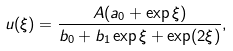<formula> <loc_0><loc_0><loc_500><loc_500>u ( \xi ) = \frac { A ( a _ { 0 } + \exp \xi ) } { b _ { 0 } + b _ { 1 } \exp \xi + \exp ( 2 \xi ) } ,</formula> 